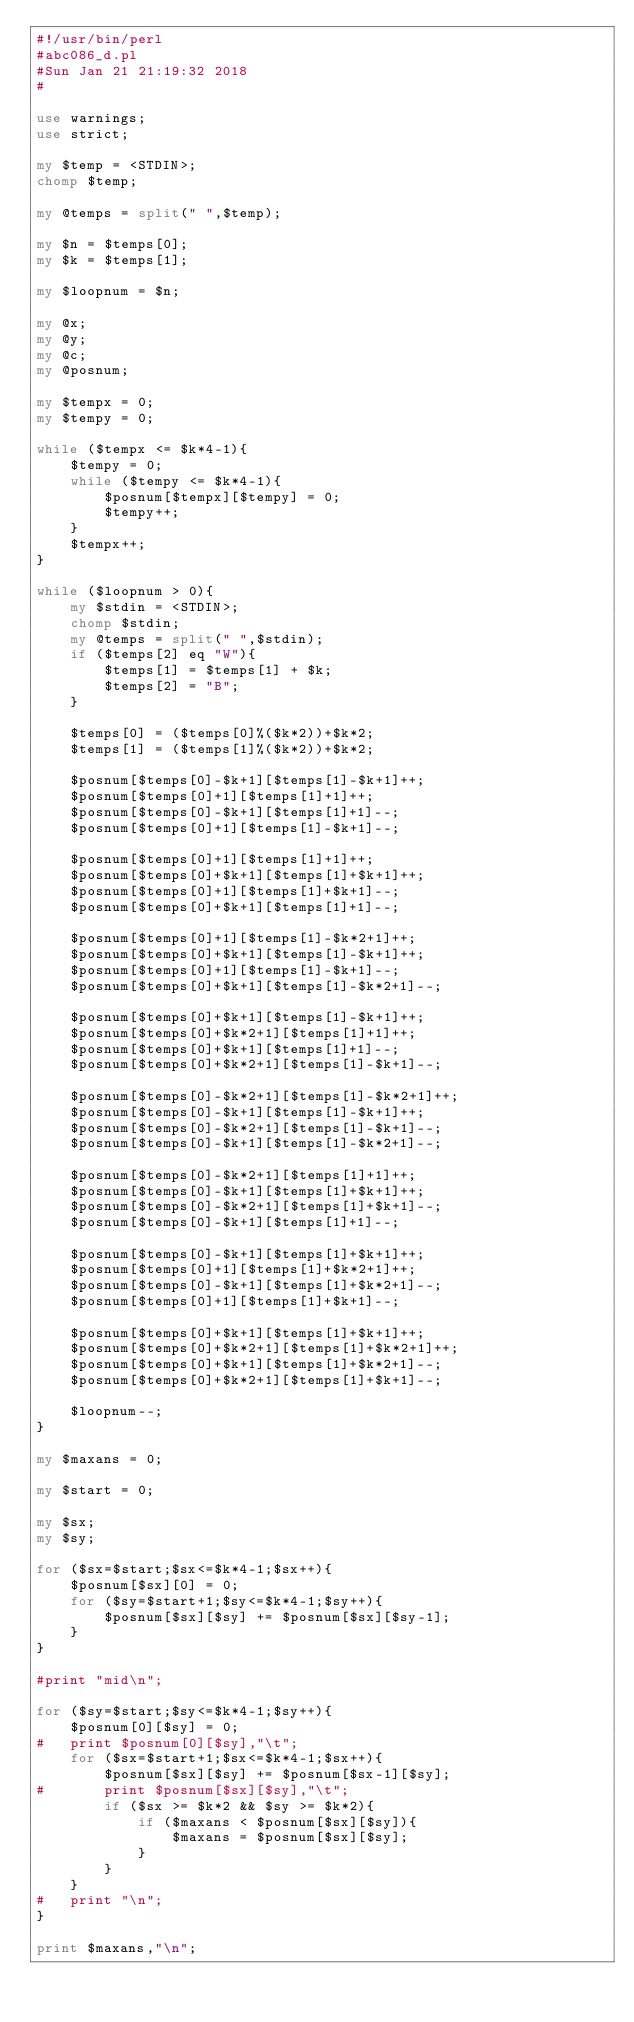<code> <loc_0><loc_0><loc_500><loc_500><_Perl_>#!/usr/bin/perl
#abc086_d.pl
#Sun Jan 21 21:19:32 2018
#

use warnings;
use strict;

my $temp = <STDIN>;
chomp $temp;

my @temps = split(" ",$temp);

my $n = $temps[0];
my $k = $temps[1];

my $loopnum = $n;

my @x;
my @y;
my @c;
my @posnum;

my $tempx = 0;
my $tempy = 0;

while ($tempx <= $k*4-1){
	$tempy = 0;
	while ($tempy <= $k*4-1){
		$posnum[$tempx][$tempy] = 0;
		$tempy++;
	}
	$tempx++;
}

while ($loopnum > 0){
	my $stdin = <STDIN>;
	chomp $stdin;
	my @temps = split(" ",$stdin);
	if ($temps[2] eq "W"){
		$temps[1] = $temps[1] + $k;
		$temps[2] = "B";
	}

	$temps[0] = ($temps[0]%($k*2))+$k*2;
	$temps[1] = ($temps[1]%($k*2))+$k*2;

	$posnum[$temps[0]-$k+1][$temps[1]-$k+1]++;
	$posnum[$temps[0]+1][$temps[1]+1]++;
	$posnum[$temps[0]-$k+1][$temps[1]+1]--;
	$posnum[$temps[0]+1][$temps[1]-$k+1]--;

	$posnum[$temps[0]+1][$temps[1]+1]++;
	$posnum[$temps[0]+$k+1][$temps[1]+$k+1]++;
	$posnum[$temps[0]+1][$temps[1]+$k+1]--;
	$posnum[$temps[0]+$k+1][$temps[1]+1]--;

	$posnum[$temps[0]+1][$temps[1]-$k*2+1]++;
	$posnum[$temps[0]+$k+1][$temps[1]-$k+1]++;
	$posnum[$temps[0]+1][$temps[1]-$k+1]--;
	$posnum[$temps[0]+$k+1][$temps[1]-$k*2+1]--;

	$posnum[$temps[0]+$k+1][$temps[1]-$k+1]++;
	$posnum[$temps[0]+$k*2+1][$temps[1]+1]++;
	$posnum[$temps[0]+$k+1][$temps[1]+1]--;
	$posnum[$temps[0]+$k*2+1][$temps[1]-$k+1]--;

	$posnum[$temps[0]-$k*2+1][$temps[1]-$k*2+1]++;
	$posnum[$temps[0]-$k+1][$temps[1]-$k+1]++;
	$posnum[$temps[0]-$k*2+1][$temps[1]-$k+1]--;
	$posnum[$temps[0]-$k+1][$temps[1]-$k*2+1]--;

	$posnum[$temps[0]-$k*2+1][$temps[1]+1]++;
	$posnum[$temps[0]-$k+1][$temps[1]+$k+1]++;
	$posnum[$temps[0]-$k*2+1][$temps[1]+$k+1]--;
	$posnum[$temps[0]-$k+1][$temps[1]+1]--;

	$posnum[$temps[0]-$k+1][$temps[1]+$k+1]++;
	$posnum[$temps[0]+1][$temps[1]+$k*2+1]++;
	$posnum[$temps[0]-$k+1][$temps[1]+$k*2+1]--;
	$posnum[$temps[0]+1][$temps[1]+$k+1]--;

	$posnum[$temps[0]+$k+1][$temps[1]+$k+1]++;
	$posnum[$temps[0]+$k*2+1][$temps[1]+$k*2+1]++;
	$posnum[$temps[0]+$k+1][$temps[1]+$k*2+1]--;
	$posnum[$temps[0]+$k*2+1][$temps[1]+$k+1]--;

	$loopnum--;
}

my $maxans = 0;

my $start = 0;

my $sx;
my $sy;

for ($sx=$start;$sx<=$k*4-1;$sx++){
	$posnum[$sx][0] = 0;
	for ($sy=$start+1;$sy<=$k*4-1;$sy++){
		$posnum[$sx][$sy] += $posnum[$sx][$sy-1];
	}
}

#print "mid\n";

for ($sy=$start;$sy<=$k*4-1;$sy++){
	$posnum[0][$sy] = 0;
#	print $posnum[0][$sy],"\t";
	for ($sx=$start+1;$sx<=$k*4-1;$sx++){
		$posnum[$sx][$sy] += $posnum[$sx-1][$sy];
#		print $posnum[$sx][$sy],"\t";
		if ($sx >= $k*2 && $sy >= $k*2){
			if ($maxans < $posnum[$sx][$sy]){
				$maxans = $posnum[$sx][$sy];
			}
		}
	}
#	print "\n";
}

print $maxans,"\n";</code> 